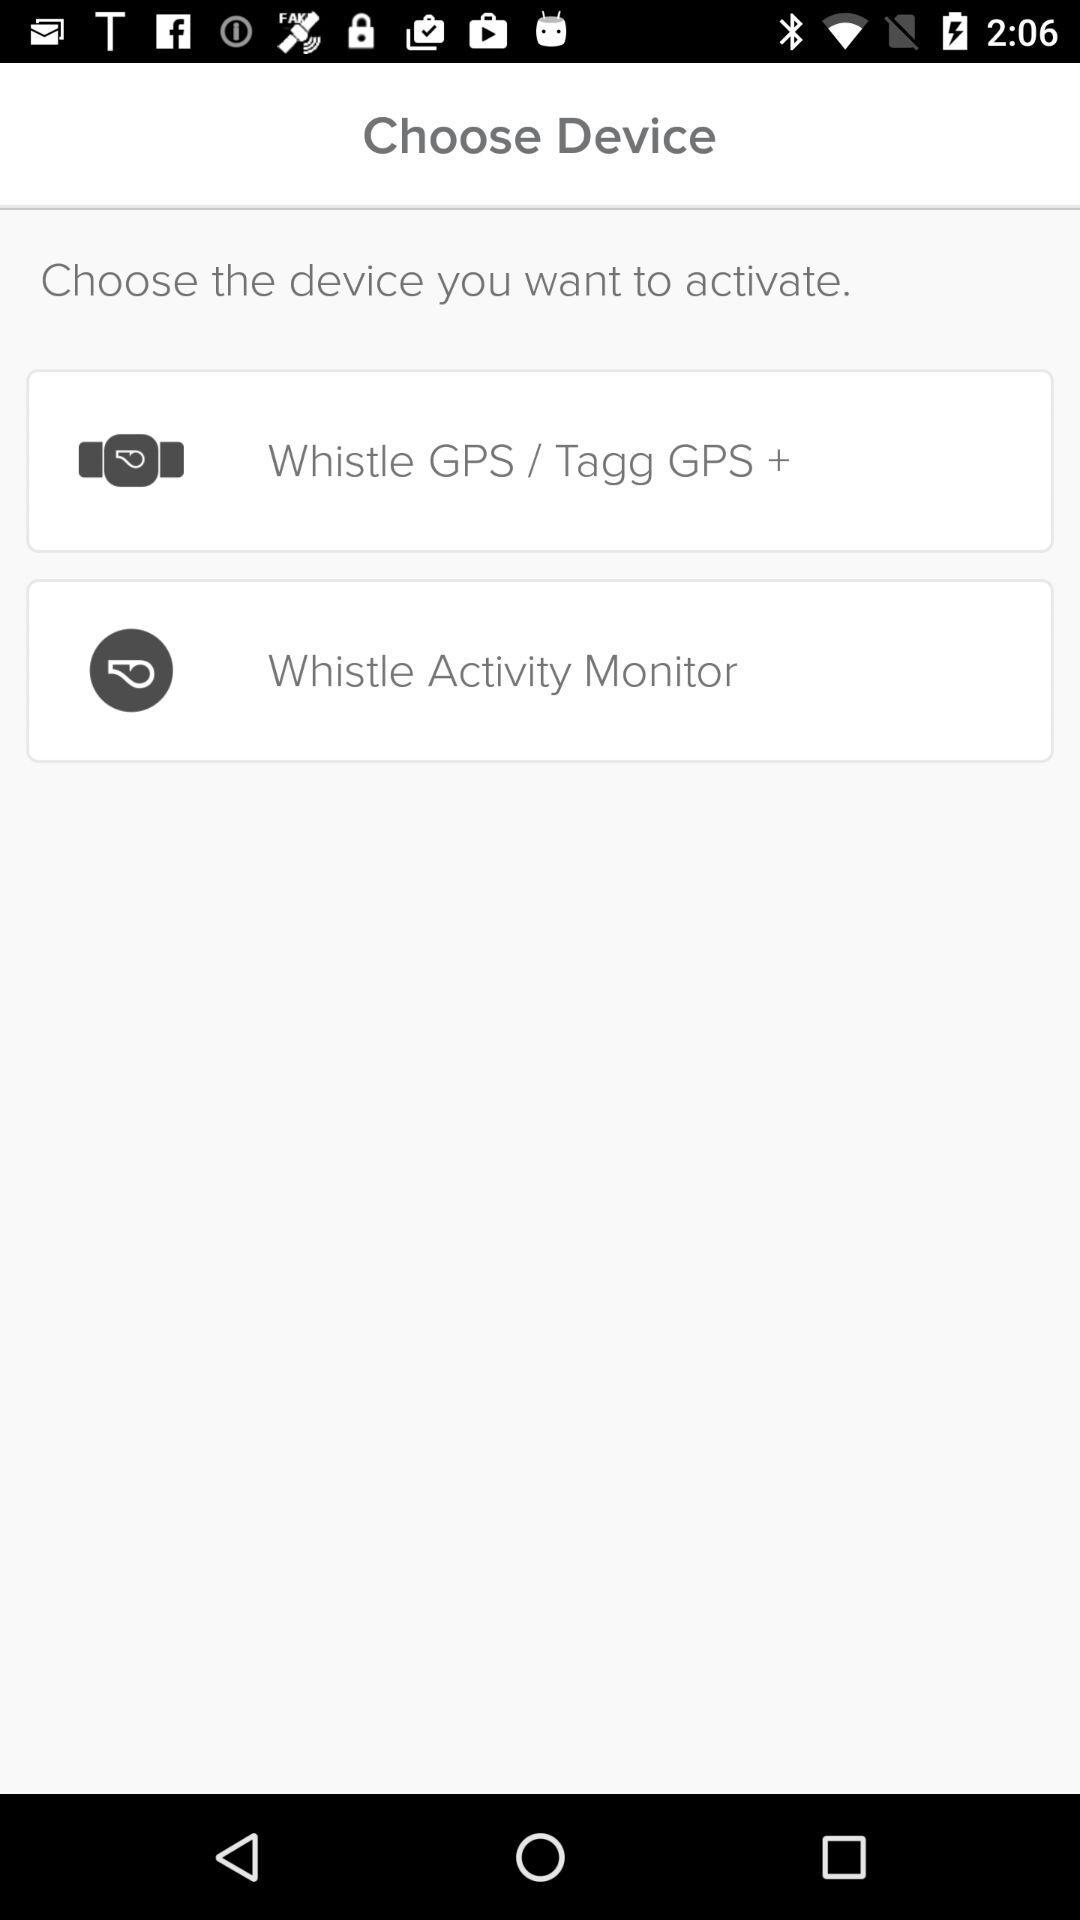How many devices are available to activate?
Answer the question using a single word or phrase. 2 